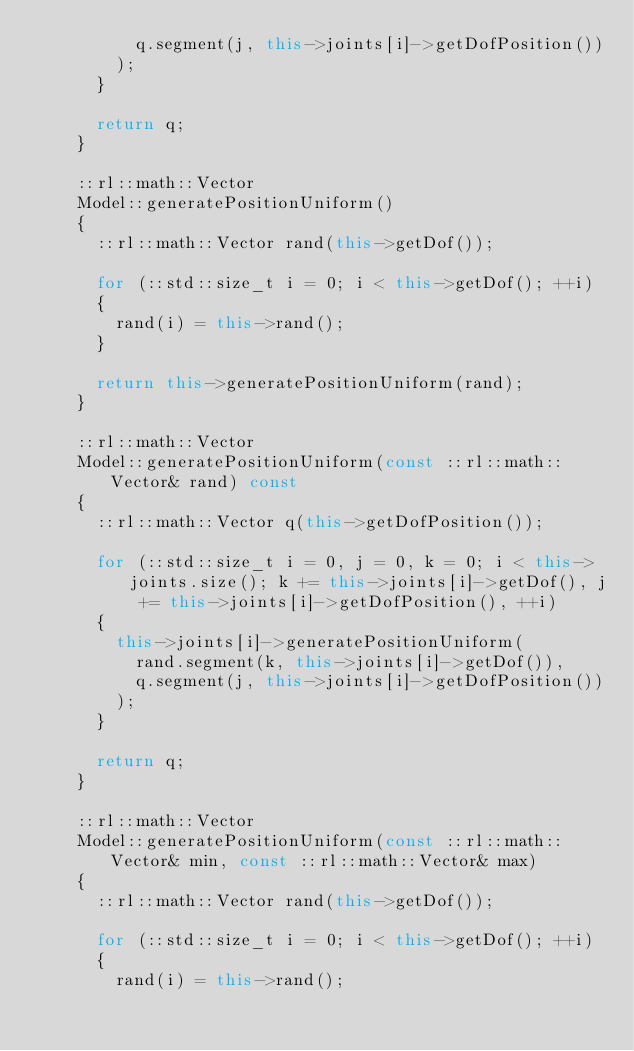<code> <loc_0><loc_0><loc_500><loc_500><_C++_>					q.segment(j, this->joints[i]->getDofPosition())
				);
			}
			
			return q;
		}
		
		::rl::math::Vector
		Model::generatePositionUniform()
		{
			::rl::math::Vector rand(this->getDof());
			
			for (::std::size_t i = 0; i < this->getDof(); ++i)
			{
				rand(i) = this->rand();
			}
			
			return this->generatePositionUniform(rand);
		}
		
		::rl::math::Vector
		Model::generatePositionUniform(const ::rl::math::Vector& rand) const
		{
			::rl::math::Vector q(this->getDofPosition());
			
			for (::std::size_t i = 0, j = 0, k = 0; i < this->joints.size(); k += this->joints[i]->getDof(), j += this->joints[i]->getDofPosition(), ++i)
			{
				this->joints[i]->generatePositionUniform(
					rand.segment(k, this->joints[i]->getDof()),
					q.segment(j, this->joints[i]->getDofPosition())
				);
			}
			
			return q;
		}
		
		::rl::math::Vector
		Model::generatePositionUniform(const ::rl::math::Vector& min, const ::rl::math::Vector& max)
		{
			::rl::math::Vector rand(this->getDof());
			
			for (::std::size_t i = 0; i < this->getDof(); ++i)
			{
				rand(i) = this->rand();</code> 